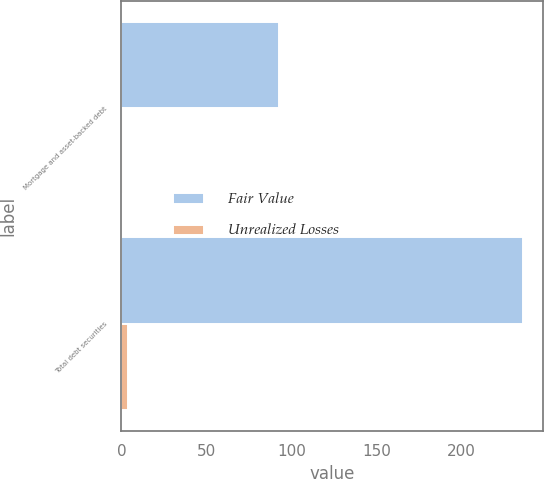Convert chart. <chart><loc_0><loc_0><loc_500><loc_500><stacked_bar_chart><ecel><fcel>Mortgage and asset-backed debt<fcel>Total debt securities<nl><fcel>Fair Value<fcel>93<fcel>236<nl><fcel>Unrealized Losses<fcel>1<fcel>4<nl></chart> 